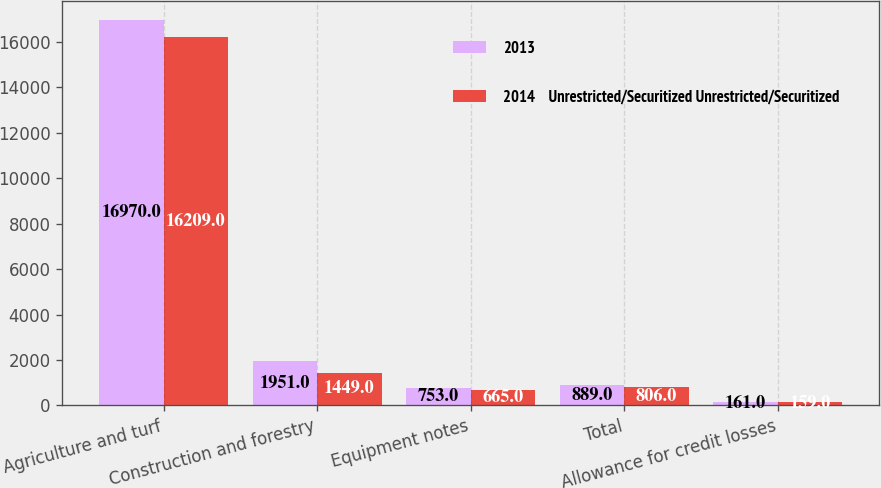Convert chart to OTSL. <chart><loc_0><loc_0><loc_500><loc_500><stacked_bar_chart><ecel><fcel>Agriculture and turf<fcel>Construction and forestry<fcel>Equipment notes<fcel>Total<fcel>Allowance for credit losses<nl><fcel>2013<fcel>16970<fcel>1951<fcel>753<fcel>889<fcel>161<nl><fcel>2014    Unrestricted/Securitized Unrestricted/Securitized<fcel>16209<fcel>1449<fcel>665<fcel>806<fcel>159<nl></chart> 